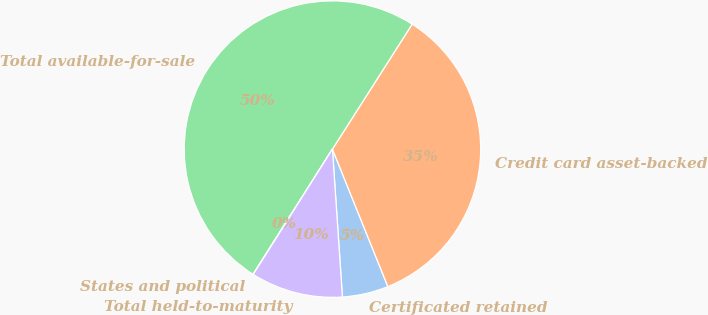Convert chart. <chart><loc_0><loc_0><loc_500><loc_500><pie_chart><fcel>Certificated retained<fcel>Credit card asset-backed<fcel>Total available-for-sale<fcel>States and political<fcel>Total held-to-maturity<nl><fcel>5.03%<fcel>34.86%<fcel>50.04%<fcel>0.03%<fcel>10.04%<nl></chart> 